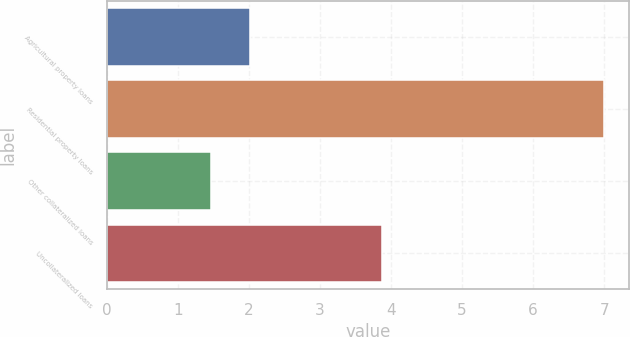Convert chart. <chart><loc_0><loc_0><loc_500><loc_500><bar_chart><fcel>Agricultural property loans<fcel>Residential property loans<fcel>Other collateralized loans<fcel>Uncollateralized loans<nl><fcel>2.01<fcel>7<fcel>1.46<fcel>3.88<nl></chart> 